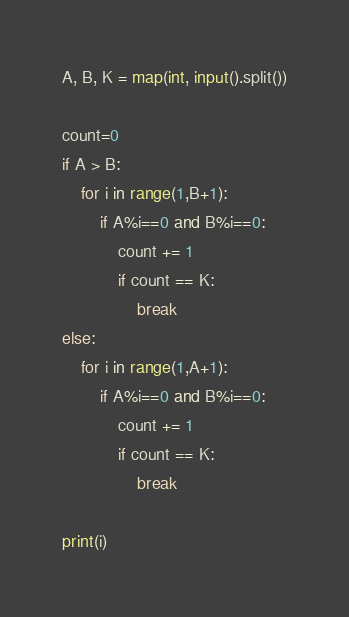<code> <loc_0><loc_0><loc_500><loc_500><_Python_>A, B, K = map(int, input().split())

count=0
if A > B:
    for i in range(1,B+1):
        if A%i==0 and B%i==0:
            count += 1
            if count == K:
                break
else:
    for i in range(1,A+1):
        if A%i==0 and B%i==0:
            count += 1
            if count == K:
                break

print(i)</code> 